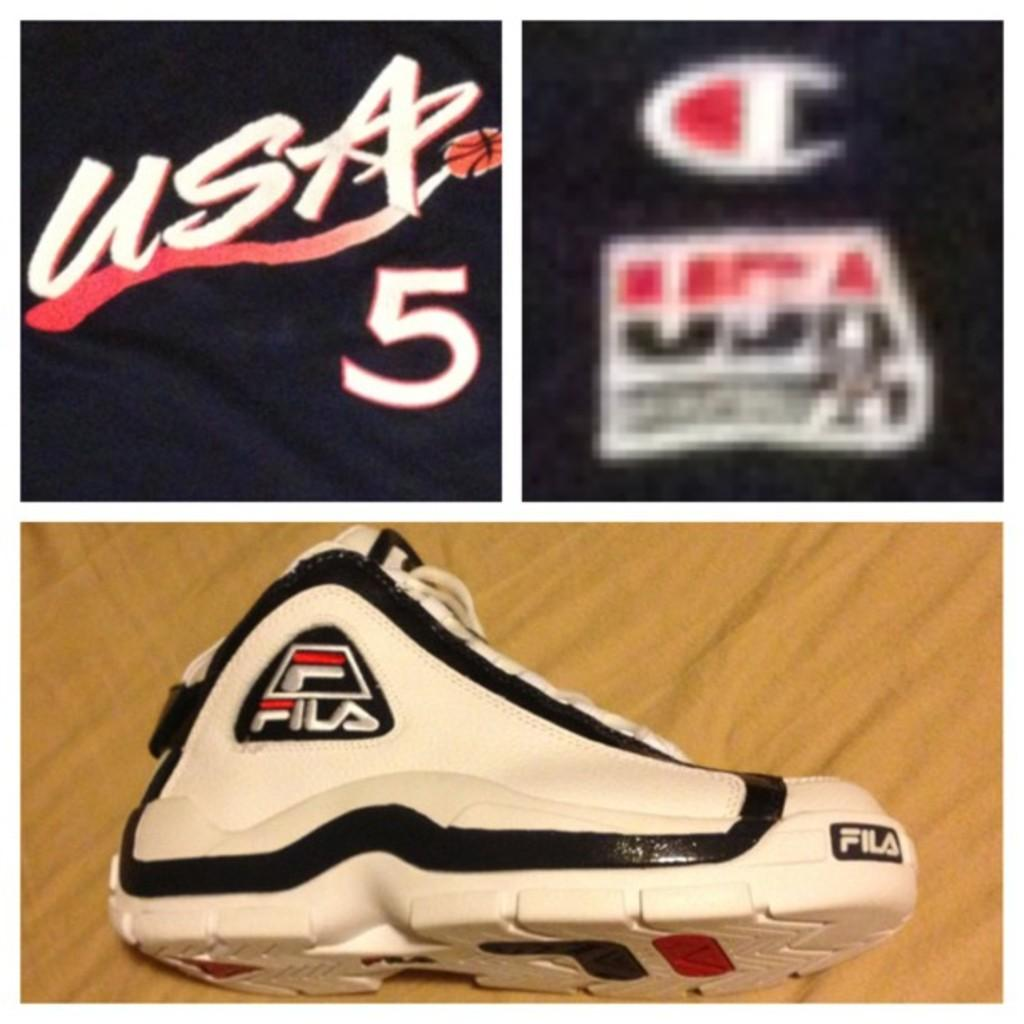<image>
Write a terse but informative summary of the picture. A white athletic shoe that says Fila and a shirt that says USA 5. 